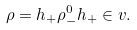Convert formula to latex. <formula><loc_0><loc_0><loc_500><loc_500>\rho = h _ { + } \rho _ { - } ^ { 0 } h _ { + } \in v .</formula> 